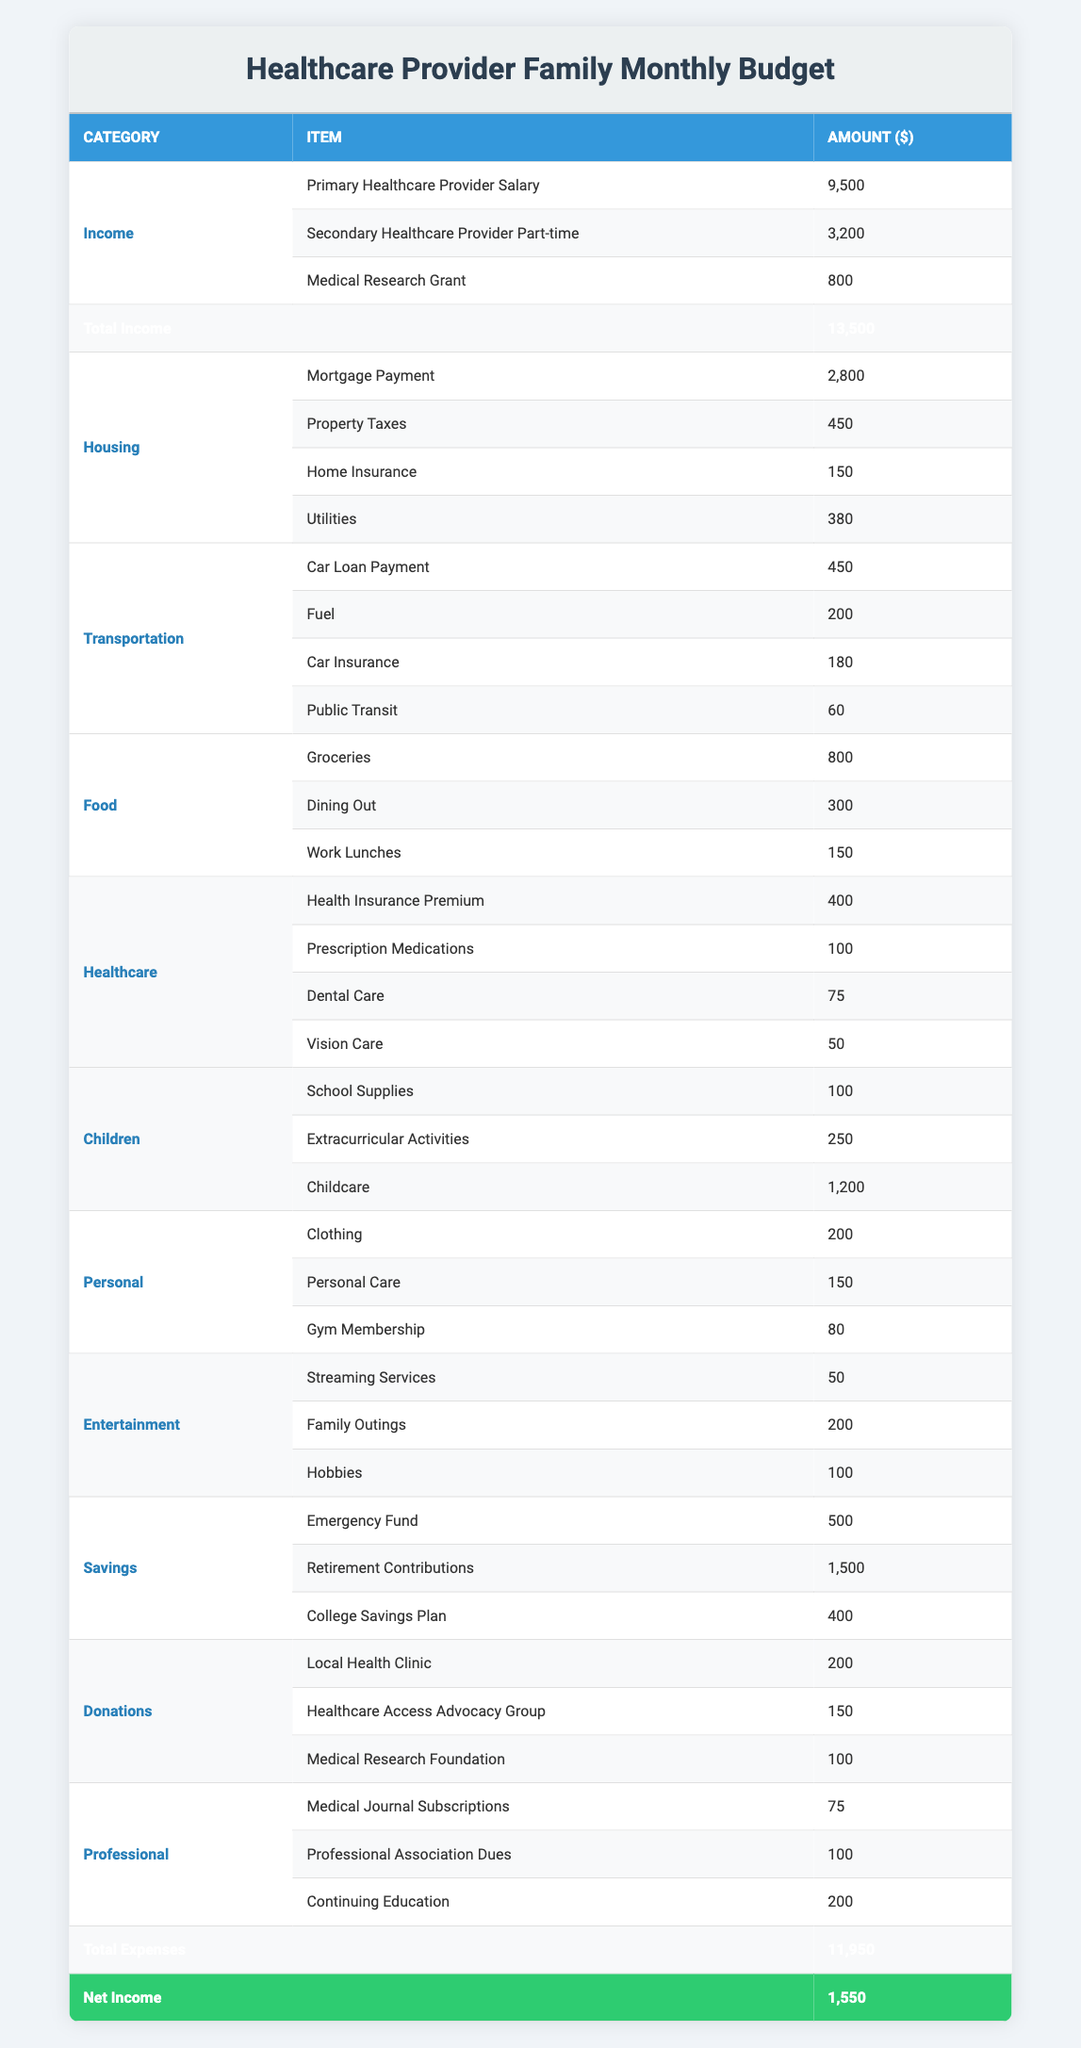What is the total income for the household? The total income is found in the last row of the Income category. We add together the three income sources: 9500 + 3200 + 800 = 13500.
Answer: 13500 What is the total spent on housing? To find the total for housing, sum the four items listed in that category: 2800 + 450 + 150 + 380 = 3780.
Answer: 3780 Is the amount spent on healthcare more than the amount spent on entertainment? We need to compare the total spent on healthcare (400 + 100 + 75 + 50 = 625) with the total spent on entertainment (50 + 200 + 100 = 350). Since 625 is greater than 350, the answer is yes.
Answer: Yes What is the net income of the household? The net income is found in the last row of the table, calculated as total income minus total expenses. The total income is 13500, and total expenses are 11950, so the net income is 13500 - 11950 = 1550.
Answer: 1550 How much does the family allocate for savings in total? To determine the total amount allocated for savings, add the three items listed under the Savings category: 500 + 1500 + 400 = 2400.
Answer: 2400 How does the amount spent on children compare to the amount spent on food? First, calculate the total spent on children (100 + 250 + 1200 = 1550) and the total spent on food (800 + 300 + 150 = 1250). Since 1550 is greater than 1250, the amount spent on children is higher.
Answer: Children spending is higher What percentage of the total income is allocated to emergency funds? The amount for emergency funds is 500, and total income is 13500. To find the percentage: (500 / 13500) * 100 = approximately 3.7%.
Answer: 3.7% What are the categories where spending exceeds 1000 dollars? Review each category and sum their items. The only category that exceeds 1000 is Children (1550).
Answer: Children Are the total vehicle-related expenses more than the total healthcare expenses? Vehicle-related expenses total 450 + 200 + 180 + 60 = 890, while total healthcare expenses are 400 + 100 + 75 + 50 = 625. Since 890 is greater than 625, yes.
Answer: Yes 